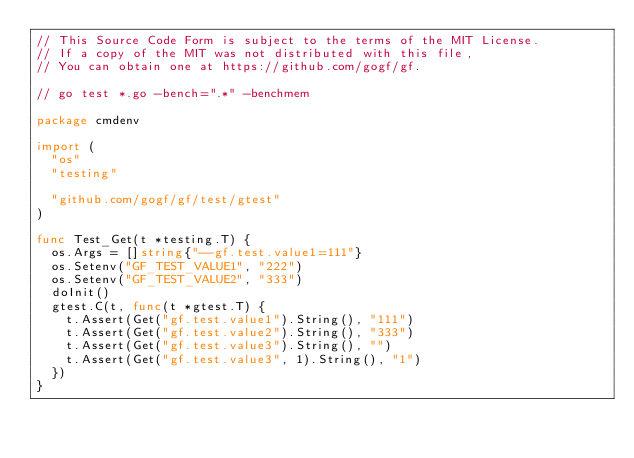<code> <loc_0><loc_0><loc_500><loc_500><_Go_>// This Source Code Form is subject to the terms of the MIT License.
// If a copy of the MIT was not distributed with this file,
// You can obtain one at https://github.com/gogf/gf.

// go test *.go -bench=".*" -benchmem

package cmdenv

import (
	"os"
	"testing"

	"github.com/gogf/gf/test/gtest"
)

func Test_Get(t *testing.T) {
	os.Args = []string{"--gf.test.value1=111"}
	os.Setenv("GF_TEST_VALUE1", "222")
	os.Setenv("GF_TEST_VALUE2", "333")
	doInit()
	gtest.C(t, func(t *gtest.T) {
		t.Assert(Get("gf.test.value1").String(), "111")
		t.Assert(Get("gf.test.value2").String(), "333")
		t.Assert(Get("gf.test.value3").String(), "")
		t.Assert(Get("gf.test.value3", 1).String(), "1")
	})
}
</code> 